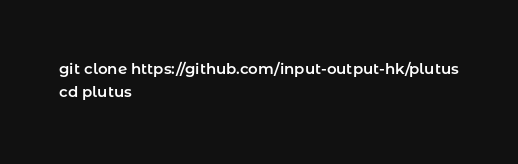Convert code to text. <code><loc_0><loc_0><loc_500><loc_500><_Bash_>git clone https://github.com/input-output-hk/plutus
cd plutus</code> 